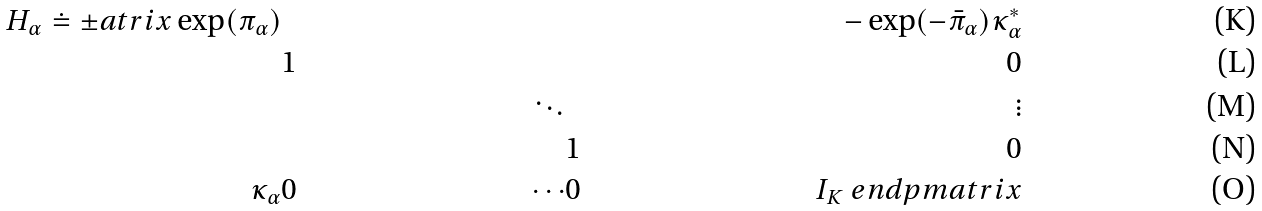Convert formula to latex. <formula><loc_0><loc_0><loc_500><loc_500>H _ { \alpha } \doteq \pm a t r i x \exp ( \pi _ { \alpha } ) & & & & - \exp ( - \bar { \pi } _ { \alpha } ) \kappa _ { \alpha } ^ { * } \\ & 1 & & & 0 \\ & & \ddots & & \vdots \\ & & & 1 & 0 \\ \kappa _ { \alpha } & 0 & \cdots & 0 & I _ { K } \ e n d p m a t r i x</formula> 